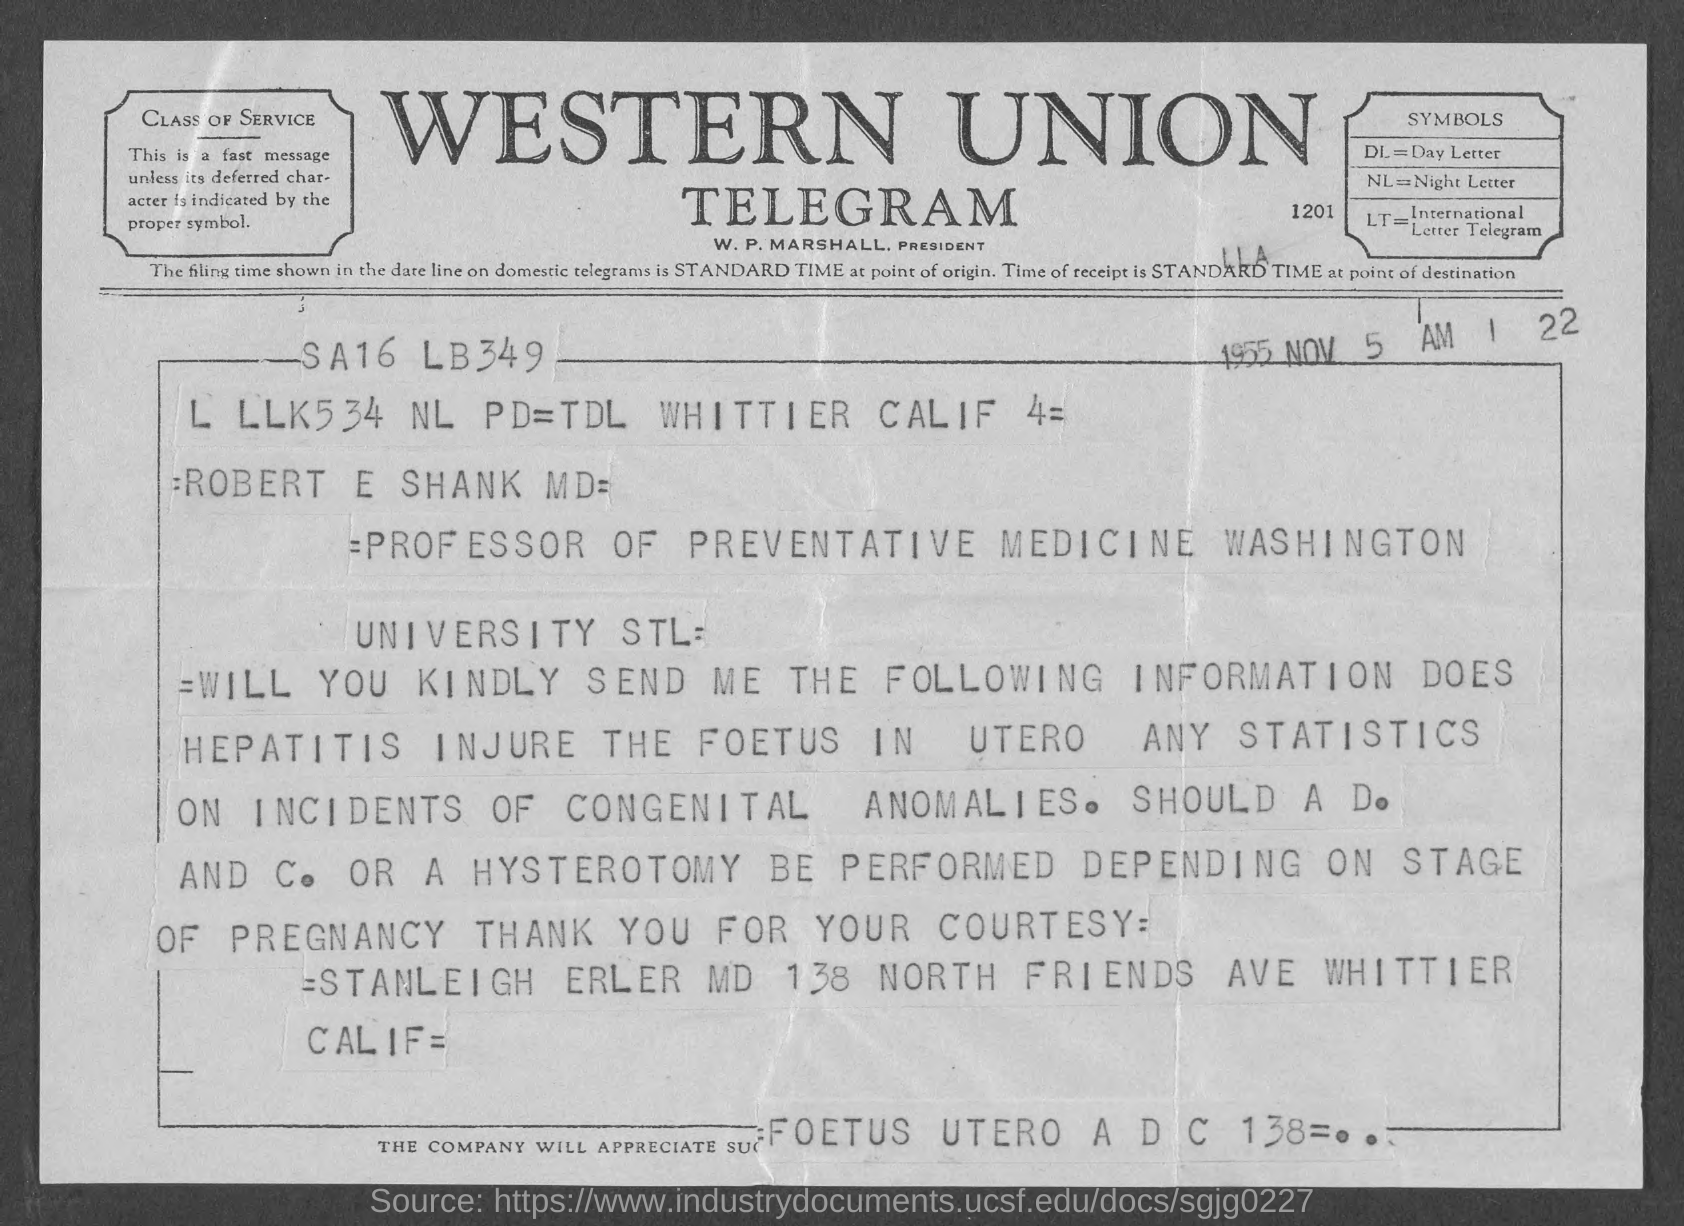What is dl=?
Make the answer very short. Day Letter. What is nl=?
Your answer should be compact. Night letter. What is lt =?
Offer a terse response. International Letter Telegram. What is the position of w.p. marshall ?
Your answer should be compact. President. 